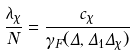Convert formula to latex. <formula><loc_0><loc_0><loc_500><loc_500>\frac { \lambda _ { \chi } } { N } = \frac { c _ { \chi } } { \gamma _ { F } ( \Delta , \Delta _ { 1 } \Delta _ { \chi } ) }</formula> 